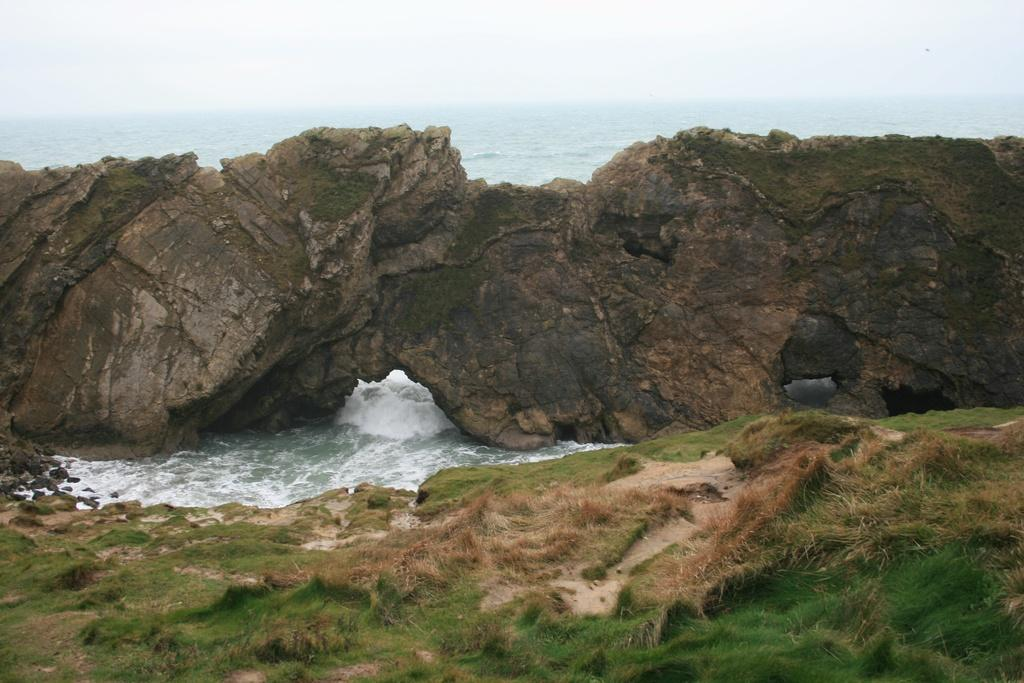What is the main subject in the middle of the image? There is a big rock in the middle of the image. What else can be seen in the image besides the rock? There is water and grass visible in the image. Can you describe the water in the image? The water is present in the image, but its specific characteristics are not mentioned in the facts. What type of vegetation is at the bottom of the image? There is grass at the bottom of the image. What type of trousers is the deer wearing in the image? There is no deer or trousers present in the image. How does the grass burn in the image? The grass does not burn in the image; there is no indication of fire or burning. 